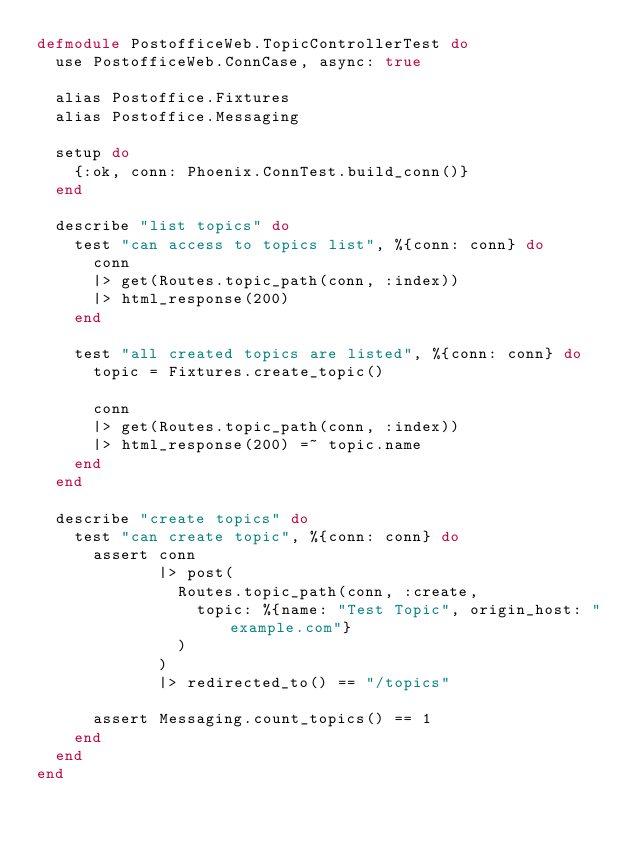Convert code to text. <code><loc_0><loc_0><loc_500><loc_500><_Elixir_>defmodule PostofficeWeb.TopicControllerTest do
  use PostofficeWeb.ConnCase, async: true

  alias Postoffice.Fixtures
  alias Postoffice.Messaging

  setup do
    {:ok, conn: Phoenix.ConnTest.build_conn()}
  end

  describe "list topics" do
    test "can access to topics list", %{conn: conn} do
      conn
      |> get(Routes.topic_path(conn, :index))
      |> html_response(200)
    end

    test "all created topics are listed", %{conn: conn} do
      topic = Fixtures.create_topic()

      conn
      |> get(Routes.topic_path(conn, :index))
      |> html_response(200) =~ topic.name
    end
  end

  describe "create topics" do
    test "can create topic", %{conn: conn} do
      assert conn
             |> post(
               Routes.topic_path(conn, :create,
                 topic: %{name: "Test Topic", origin_host: "example.com"}
               )
             )
             |> redirected_to() == "/topics"

      assert Messaging.count_topics() == 1
    end
  end
end
</code> 